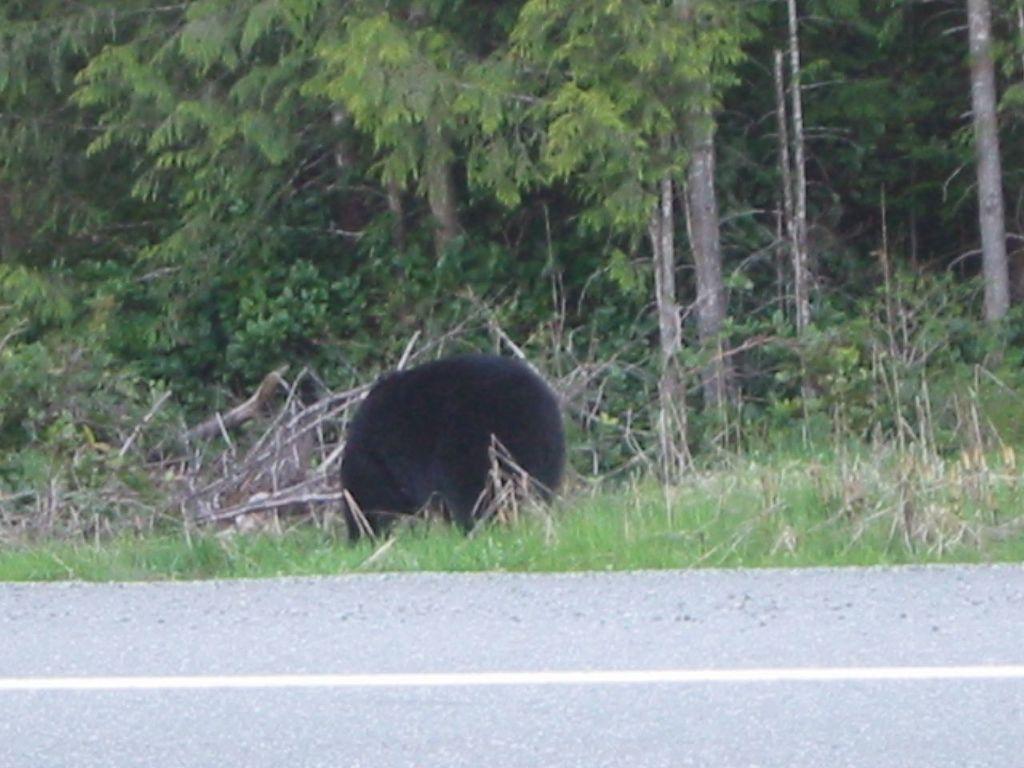Can you describe this image briefly? In this picture we can see a bear standing here, at the bottom there is grass, we can see some trees in the background, there is road here. 